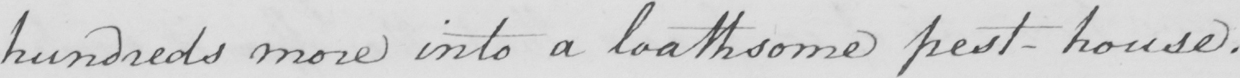Please transcribe the handwritten text in this image. hundreds more into a loathsome pest-house . 